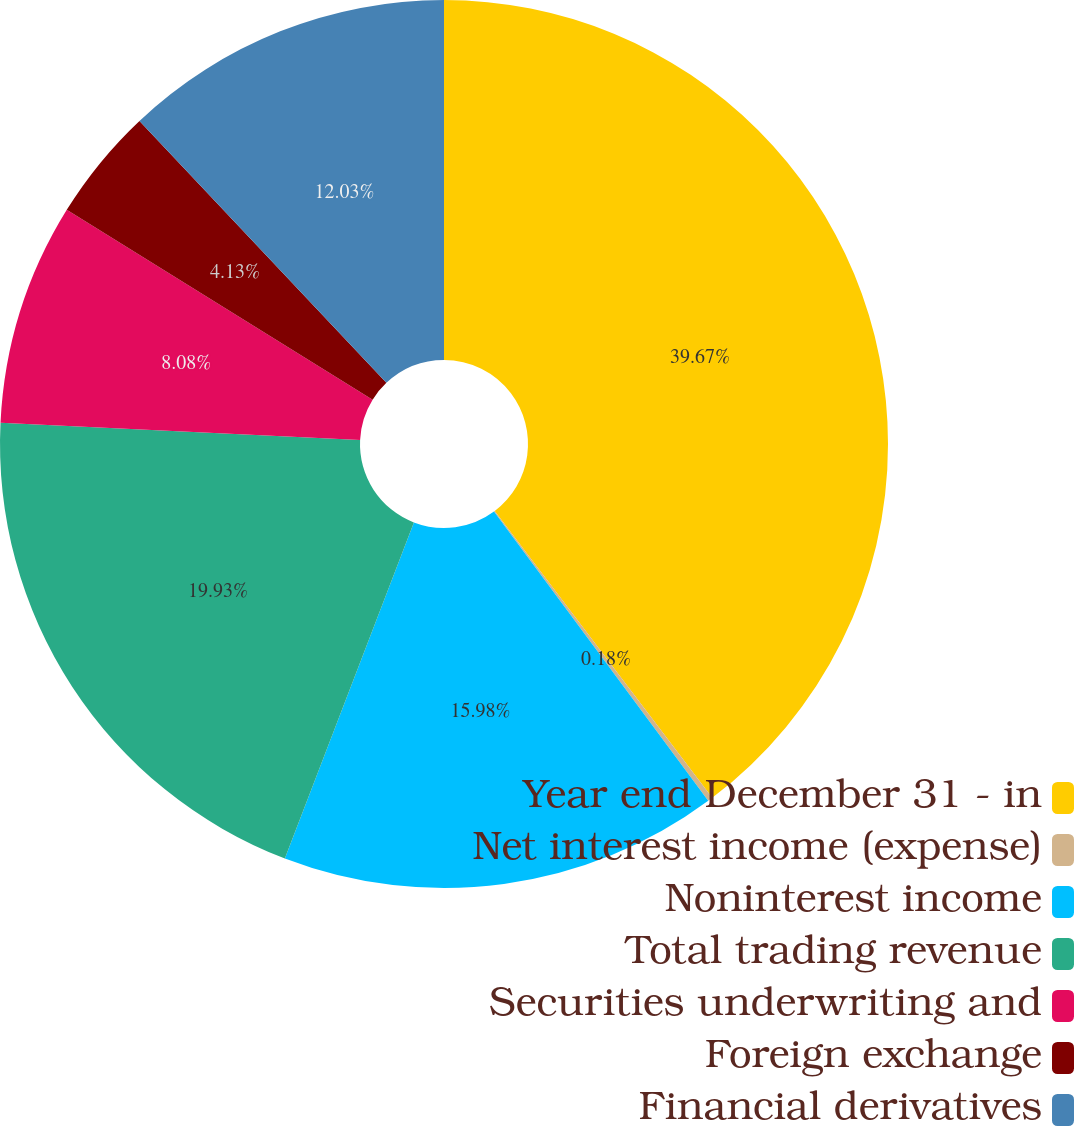Convert chart. <chart><loc_0><loc_0><loc_500><loc_500><pie_chart><fcel>Year end December 31 - in<fcel>Net interest income (expense)<fcel>Noninterest income<fcel>Total trading revenue<fcel>Securities underwriting and<fcel>Foreign exchange<fcel>Financial derivatives<nl><fcel>39.68%<fcel>0.18%<fcel>15.98%<fcel>19.93%<fcel>8.08%<fcel>4.13%<fcel>12.03%<nl></chart> 